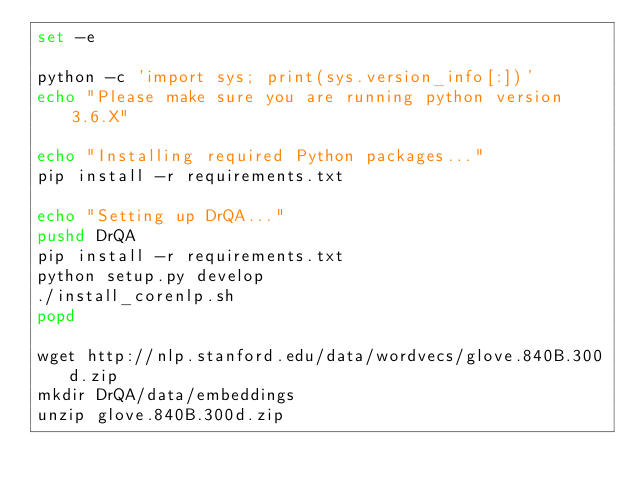Convert code to text. <code><loc_0><loc_0><loc_500><loc_500><_Bash_>set -e

python -c 'import sys; print(sys.version_info[:])'
echo "Please make sure you are running python version 3.6.X"

echo "Installing required Python packages..."
pip install -r requirements.txt

echo "Setting up DrQA..."
pushd DrQA
pip install -r requirements.txt
python setup.py develop
./install_corenlp.sh
popd

wget http://nlp.stanford.edu/data/wordvecs/glove.840B.300d.zip
mkdir DrQA/data/embeddings
unzip glove.840B.300d.zip</code> 